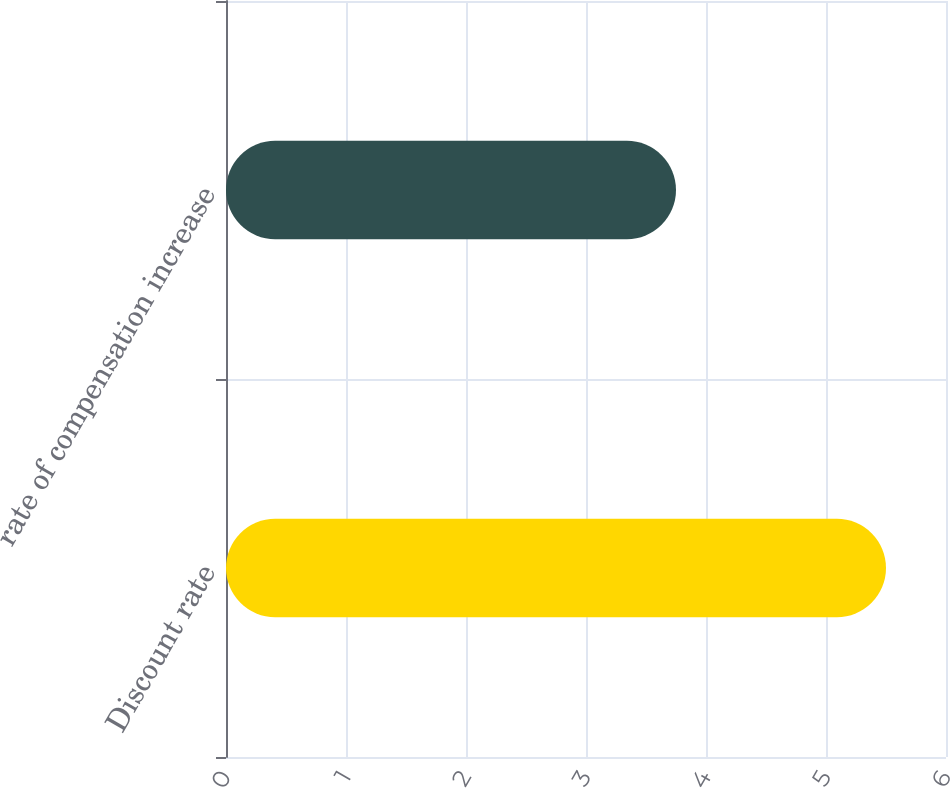Convert chart to OTSL. <chart><loc_0><loc_0><loc_500><loc_500><bar_chart><fcel>Discount rate<fcel>rate of compensation increase<nl><fcel>5.5<fcel>3.75<nl></chart> 